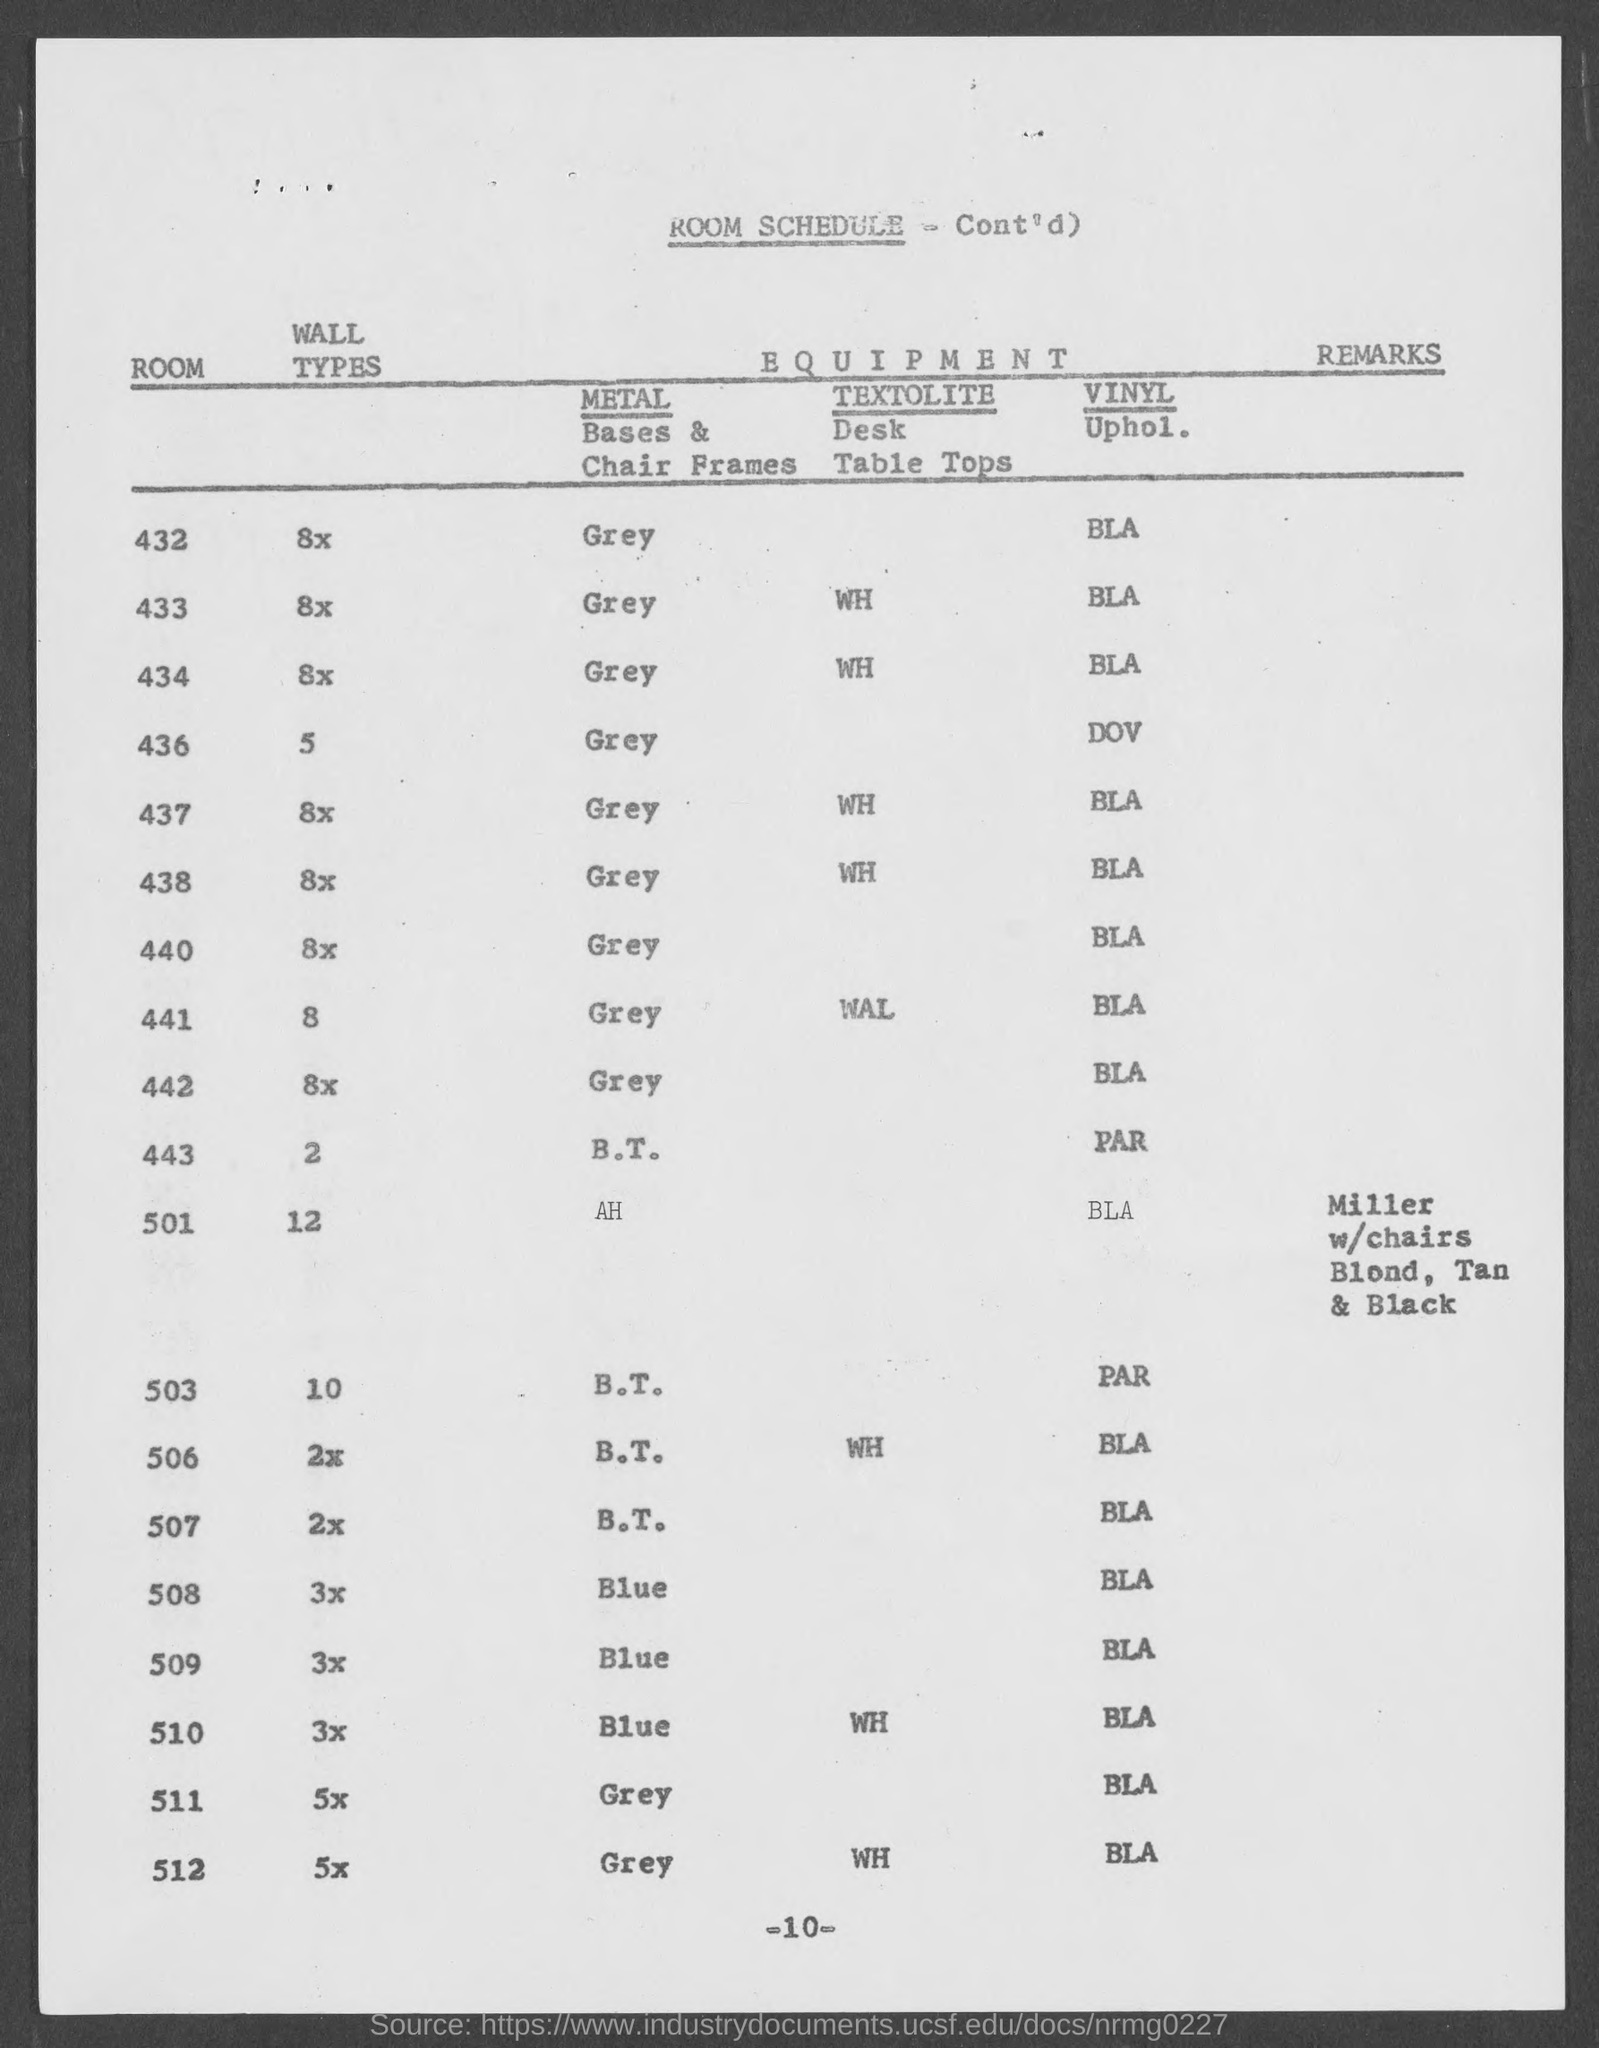List a handful of essential elements in this visual. The metal bases and chair frames used in Room 432 are of a grey color. According to the room schedule, Room 508 has a wall type that is used for its purpose. According to the room schedule, the wall type for Room 433 is [insert wall type]. The wall type for Room 501, as per the room schedule, is [object]. The document contains information about a schedule, specifically a room schedule. 